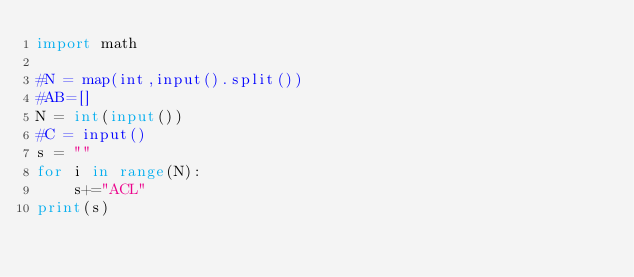Convert code to text. <code><loc_0><loc_0><loc_500><loc_500><_Python_>import math

#N = map(int,input().split())
#AB=[]
N = int(input())
#C = input()
s = ""
for i in range(N):
    s+="ACL"
print(s)</code> 